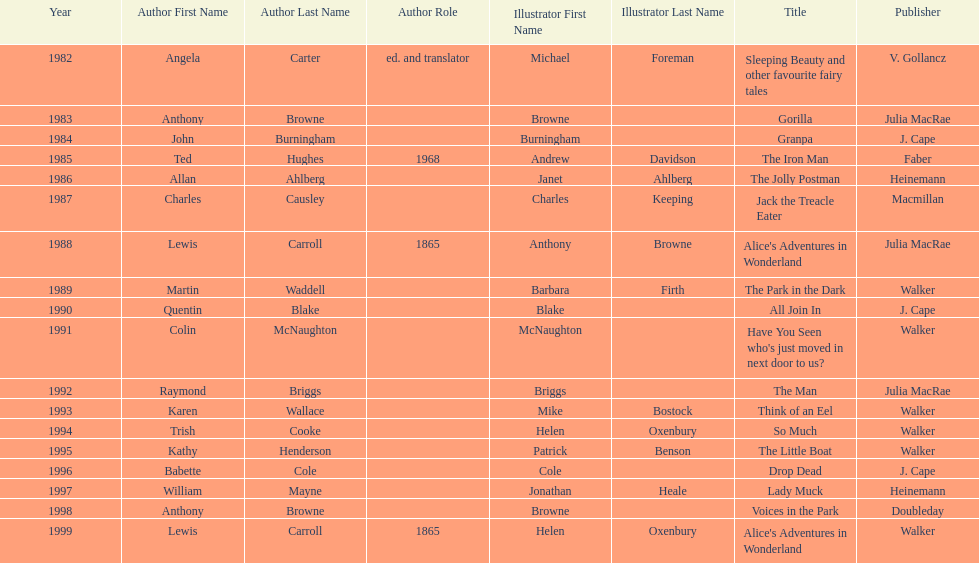How many titles did walker publish? 6. 